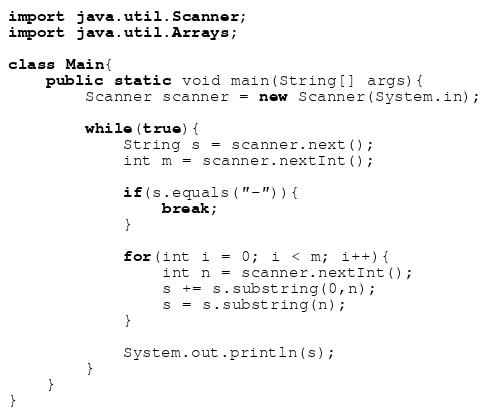Convert code to text. <code><loc_0><loc_0><loc_500><loc_500><_Java_>import java.util.Scanner;
import java.util.Arrays;

class Main{
	public static void main(String[] args){
		Scanner scanner = new Scanner(System.in);

		while(true){
			String s = scanner.next();
			int m = scanner.nextInt();

			if(s.equals("-")){
				break;
			}

			for(int i = 0; i < m; i++){
				int n = scanner.nextInt();
				s += s.substring(0,n);
				s = s.substring(n);
			}

			System.out.println(s);
		}
	}
}</code> 